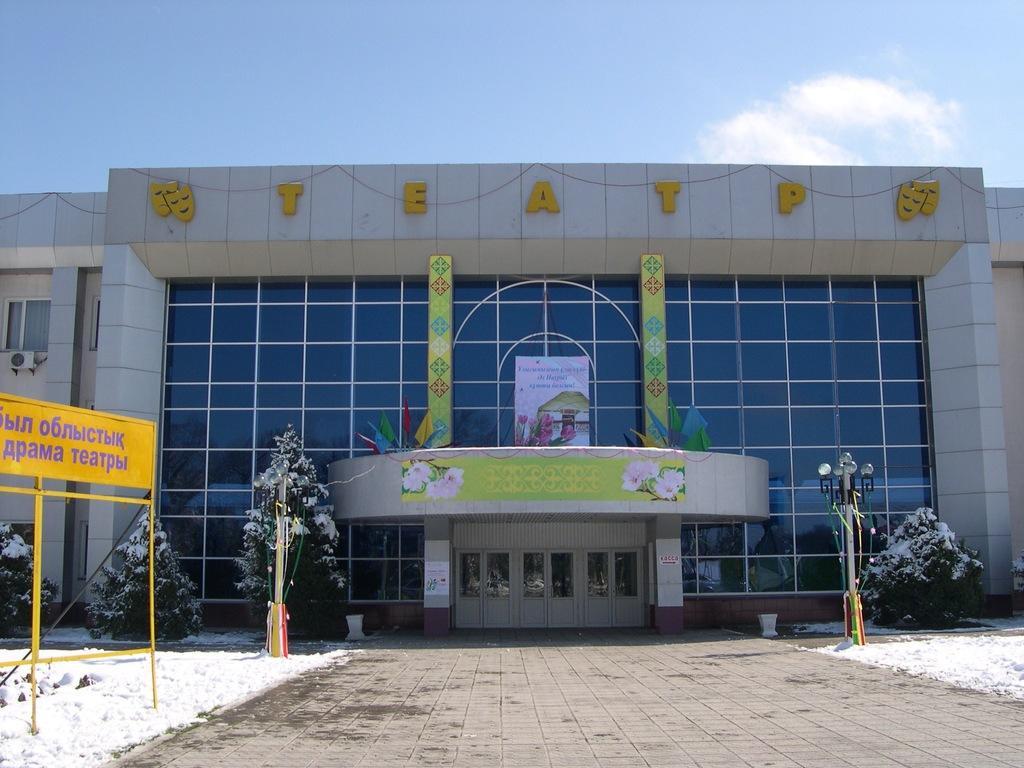In one or two sentences, can you explain what this image depicts? In this image we can see a building. In front of the building, we can see light poles, plants, pavement and land covered with ice. There is a board on the left side of the image. At the top of the image, we can see the sky with some clouds. 